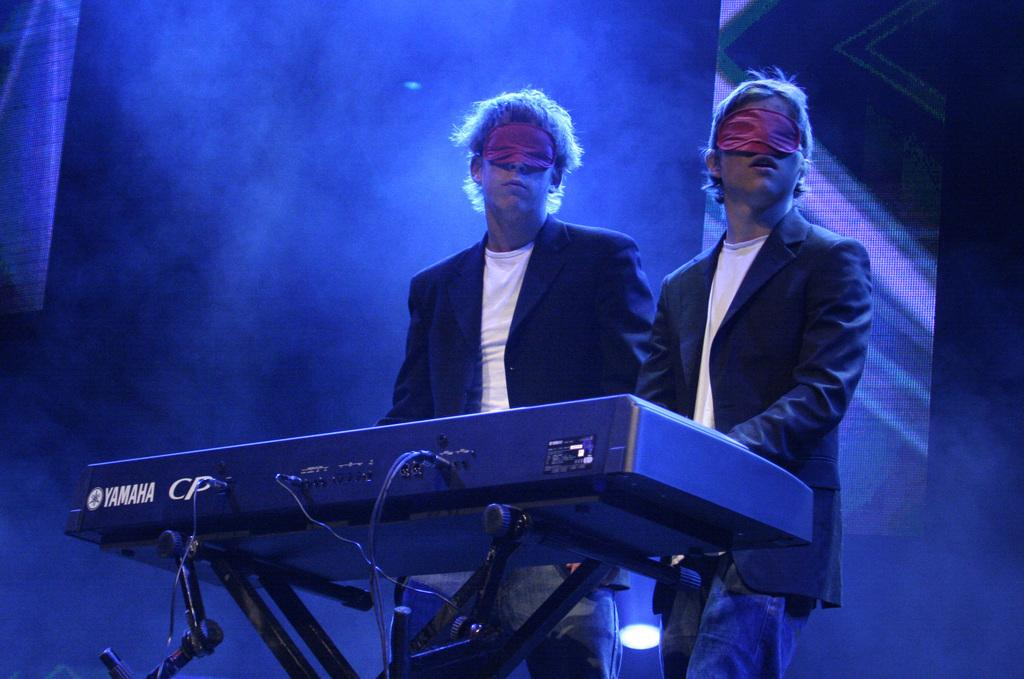What is happening in the image? There are people standing in the image. What object can be seen with the people? There is a musical instrument in the image. Can you describe the musical instrument? The musical instrument has text on it. What else is present in the image? There are screens in the image. What language is your aunt speaking in the image? There is no aunt present in the image, and therefore no language can be attributed to her. 